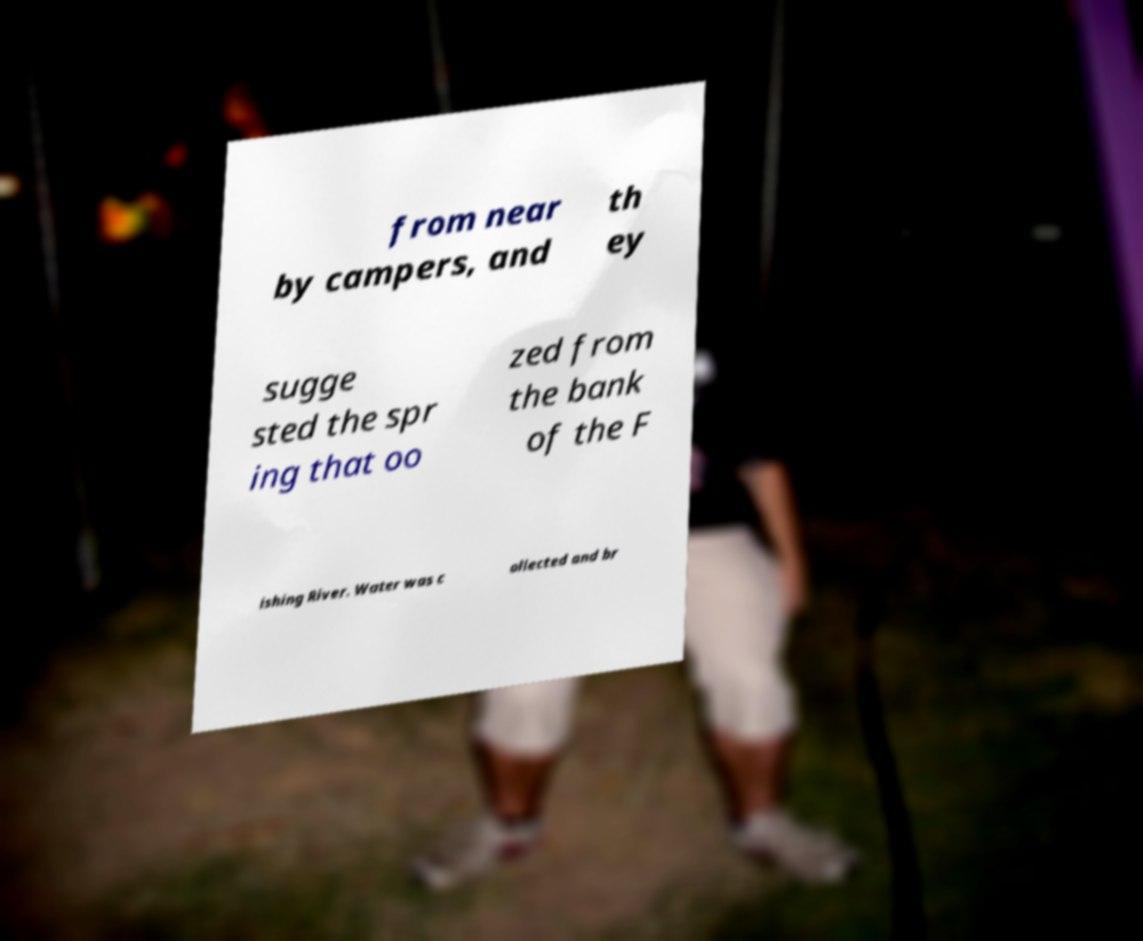Could you extract and type out the text from this image? from near by campers, and th ey sugge sted the spr ing that oo zed from the bank of the F ishing River. Water was c ollected and br 